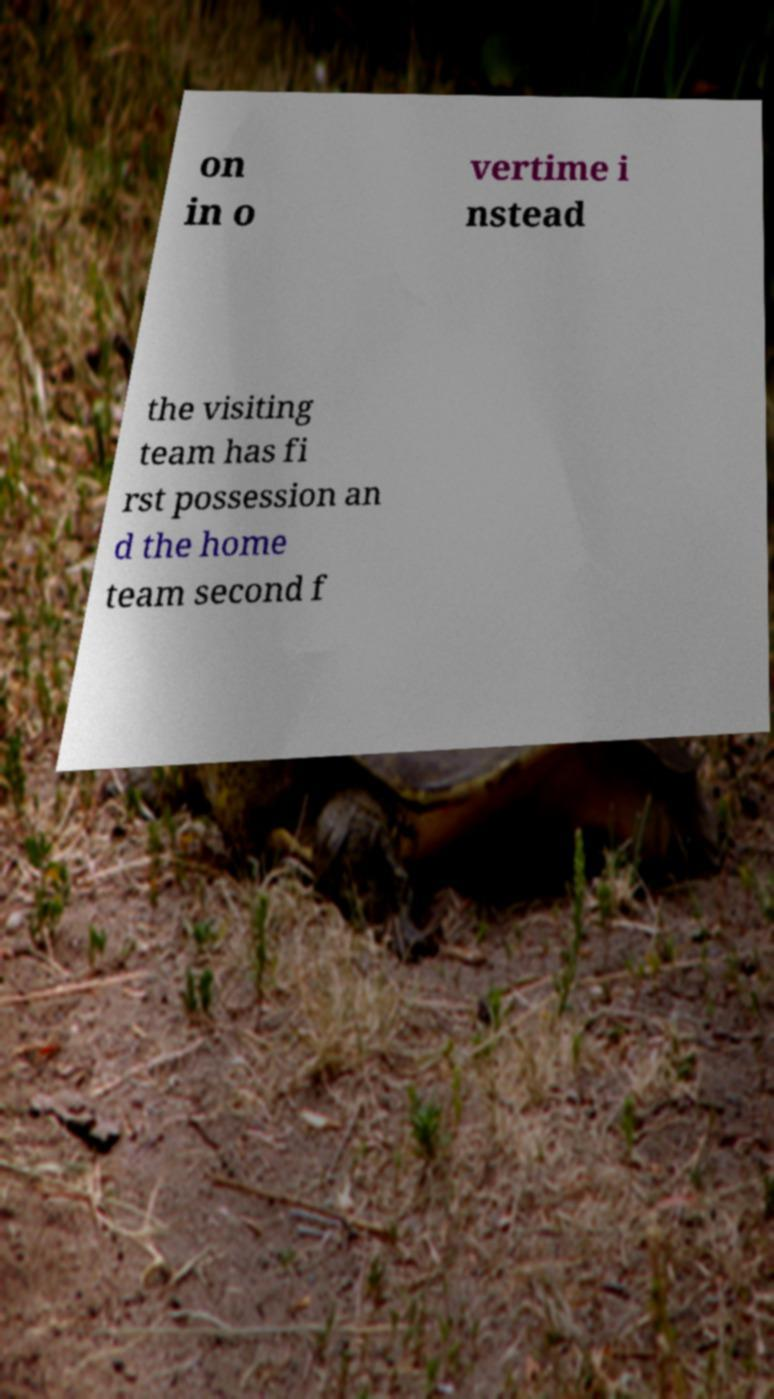Could you extract and type out the text from this image? on in o vertime i nstead the visiting team has fi rst possession an d the home team second f 